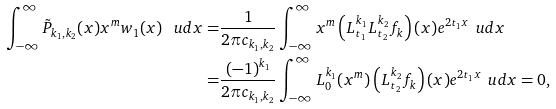Convert formula to latex. <formula><loc_0><loc_0><loc_500><loc_500>\int _ { - \infty } ^ { \infty } \tilde { P } _ { k _ { 1 } , k _ { 2 } } ( x ) x ^ { m } w _ { 1 } ( x ) \, \ u d x = & \frac { 1 } { 2 \pi c _ { k _ { 1 } , k _ { 2 } } } \int _ { - \infty } ^ { \infty } x ^ { m } \left ( L _ { t _ { 1 } } ^ { k _ { 1 } } L _ { t _ { 2 } } ^ { k _ { 2 } } f _ { k } \right ) ( x ) e ^ { 2 t _ { 1 } x } \, \ u d x \\ = & \frac { ( - 1 ) ^ { k _ { 1 } } } { 2 \pi c _ { k _ { 1 } , k _ { 2 } } } \int _ { - \infty } ^ { \infty } L _ { 0 } ^ { k _ { 1 } } ( x ^ { m } ) \left ( L _ { t _ { 2 } } ^ { k _ { 2 } } f _ { k } \right ) ( x ) e ^ { 2 t _ { 1 } x } \, \ u d x = 0 ,</formula> 